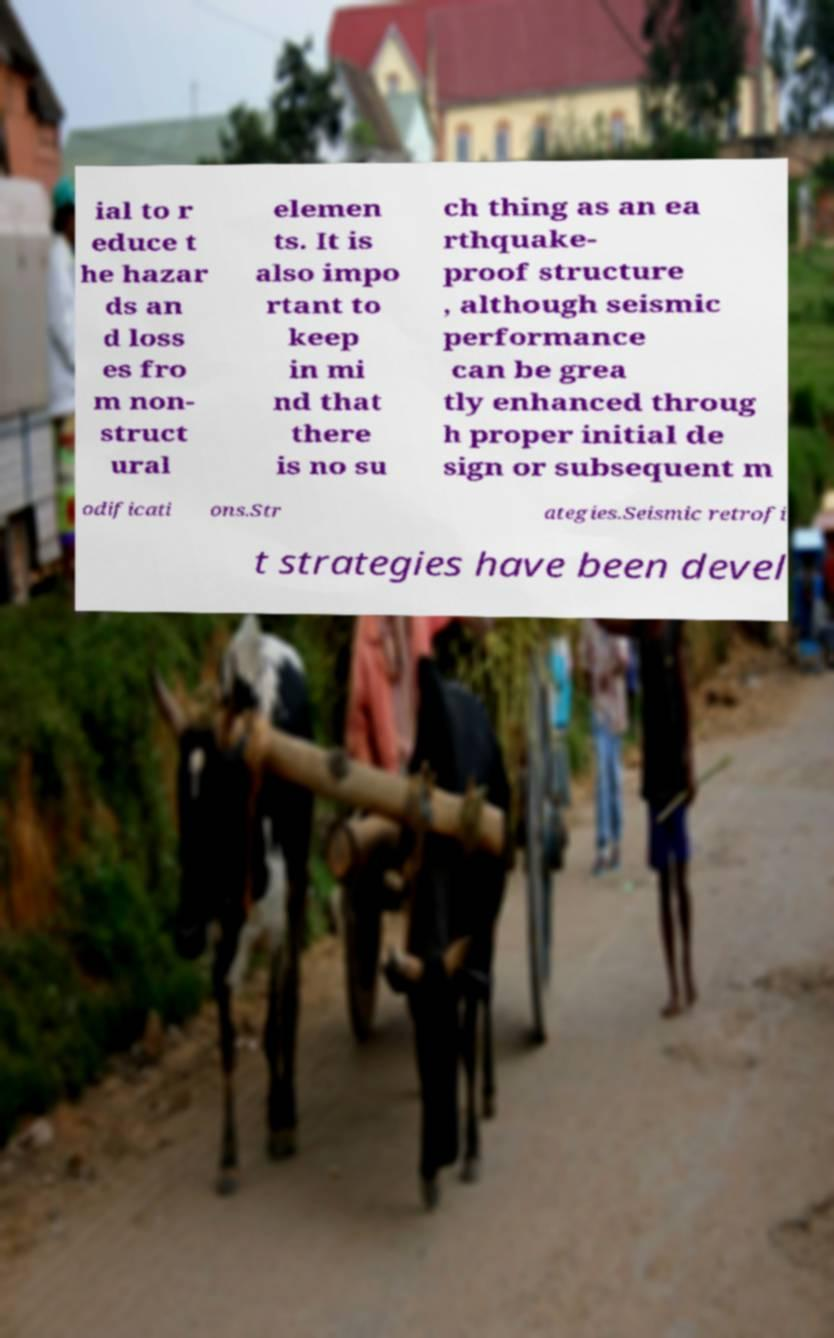What messages or text are displayed in this image? I need them in a readable, typed format. ial to r educe t he hazar ds an d loss es fro m non- struct ural elemen ts. It is also impo rtant to keep in mi nd that there is no su ch thing as an ea rthquake- proof structure , although seismic performance can be grea tly enhanced throug h proper initial de sign or subsequent m odificati ons.Str ategies.Seismic retrofi t strategies have been devel 